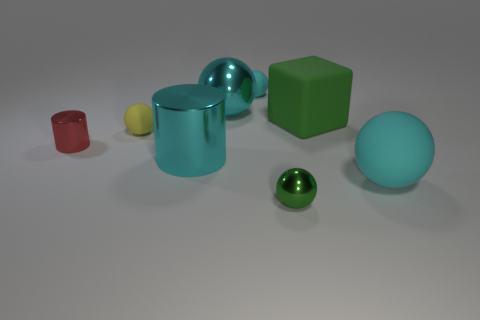The sphere that is to the right of the cyan metallic sphere and behind the big green matte thing is what color?
Provide a short and direct response. Cyan. Is there a tiny sphere of the same color as the large rubber cube?
Make the answer very short. Yes. The tiny object that is behind the cyan metallic sphere is what color?
Provide a succinct answer. Cyan. There is a cyan matte thing in front of the cyan cylinder; are there any big blocks in front of it?
Give a very brief answer. No. There is a large block; is its color the same as the large metal object that is in front of the small yellow rubber sphere?
Your answer should be compact. No. Is there a large thing that has the same material as the green block?
Give a very brief answer. Yes. What number of blocks are there?
Keep it short and to the point. 1. The green thing that is behind the big cyan metal cylinder that is in front of the red shiny cylinder is made of what material?
Provide a succinct answer. Rubber. There is a large object that is the same material as the large green block; what is its color?
Your answer should be very brief. Cyan. There is a big matte thing that is the same color as the big metallic ball; what shape is it?
Your answer should be very brief. Sphere. 